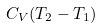<formula> <loc_0><loc_0><loc_500><loc_500>C _ { V } ( T _ { 2 } - T _ { 1 } )</formula> 